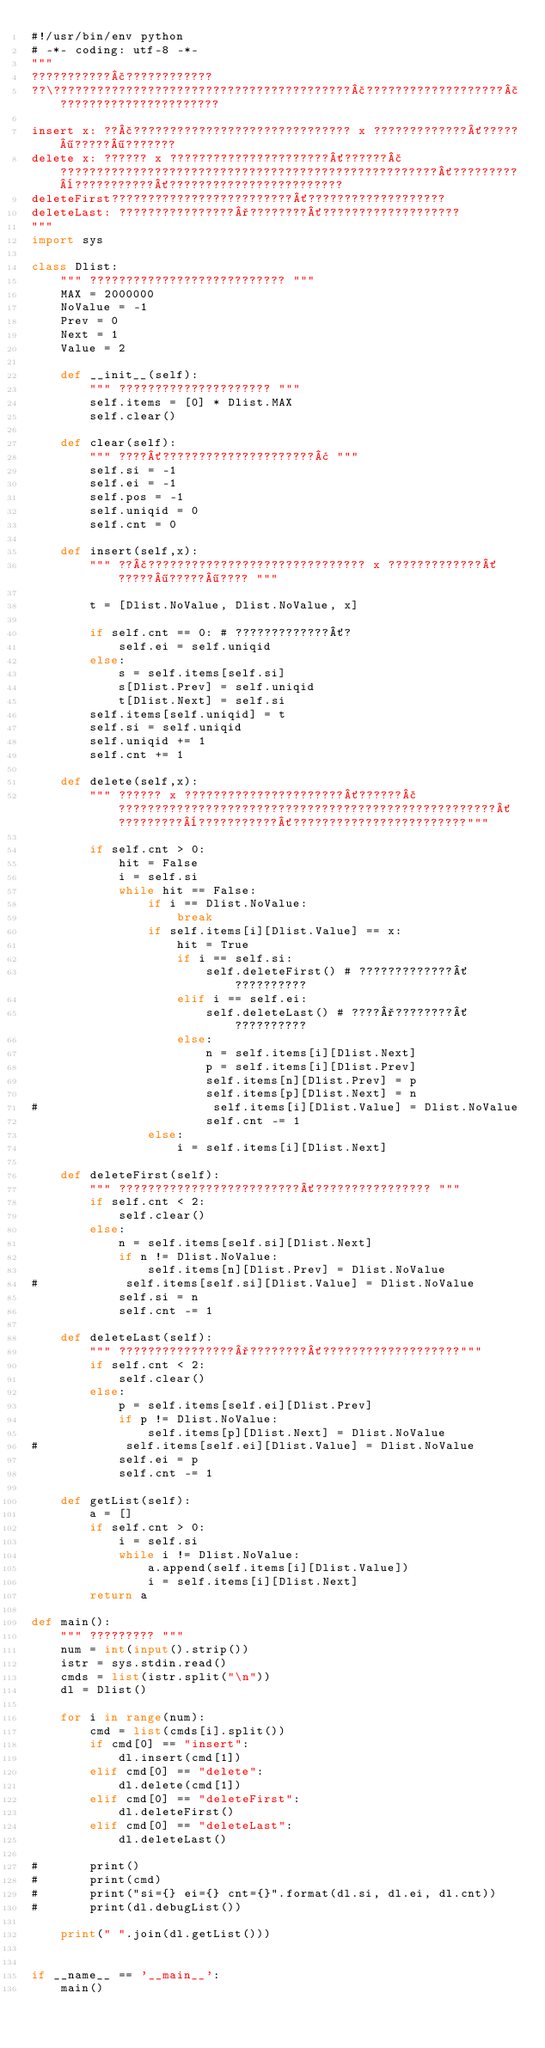<code> <loc_0><loc_0><loc_500><loc_500><_Python_>#!/usr/bin/env python
# -*- coding: utf-8 -*-
"""
???????????£????????????
??\?????????????????????????????????????????£???????????????????£??????????????????????

insert x: ??£?????????????????????????????? x ?????????????´?????¶?????¶???????
delete x: ?????? x ??????????????????????´??????£????????????????????????????????????????????????????´?????????¨???????????´????????????????????????
deleteFirst?????????????????????????´???????????????????
deleteLast: ????????????????°????????´???????????????????
"""
import sys

class Dlist:
    """ ??????????????????????????? """
    MAX = 2000000
    NoValue = -1
    Prev = 0
    Next = 1
    Value = 2

    def __init__(self):
        """ ????????????????????? """
        self.items = [0] * Dlist.MAX
        self.clear()

    def clear(self):
        """ ????´?????????????????????¢ """
        self.si = -1
        self.ei = -1
        self.pos = -1
        self.uniqid = 0
        self.cnt = 0
        
    def insert(self,x):
        """ ??£?????????????????????????????? x ?????????????´?????¶?????¶???? """

        t = [Dlist.NoValue, Dlist.NoValue, x]

        if self.cnt == 0: # ?????????????´?
            self.ei = self.uniqid
        else:
            s = self.items[self.si]
            s[Dlist.Prev] = self.uniqid
            t[Dlist.Next] = self.si
        self.items[self.uniqid] = t
        self.si = self.uniqid
        self.uniqid += 1
        self.cnt += 1
    
    def delete(self,x):
        """ ?????? x ??????????????????????´??????£????????????????????????????????????????????????????´?????????¨???????????´????????????????????????"""

        if self.cnt > 0:
            hit = False
            i = self.si
            while hit == False:
                if i == Dlist.NoValue:
                    break
                if self.items[i][Dlist.Value] == x:
                    hit = True
                    if i == self.si:
                        self.deleteFirst() # ?????????????´??????????
                    elif i == self.ei:
                        self.deleteLast() # ????°????????´??????????
                    else:
                        n = self.items[i][Dlist.Next]
                        p = self.items[i][Dlist.Prev]
                        self.items[n][Dlist.Prev] = p
                        self.items[p][Dlist.Next] = n
#                        self.items[i][Dlist.Value] = Dlist.NoValue
                        self.cnt -= 1
                else:
                    i = self.items[i][Dlist.Next]

    def deleteFirst(self):
        """ ?????????????????????????´???????????????? """
        if self.cnt < 2:
            self.clear()
        else:
            n = self.items[self.si][Dlist.Next]
            if n != Dlist.NoValue:
                self.items[n][Dlist.Prev] = Dlist.NoValue
#            self.items[self.si][Dlist.Value] = Dlist.NoValue
            self.si = n
            self.cnt -= 1

    def deleteLast(self):
        """ ????????????????°????????´???????????????????"""
        if self.cnt < 2:
            self.clear()
        else:
            p = self.items[self.ei][Dlist.Prev]
            if p != Dlist.NoValue:
                self.items[p][Dlist.Next] = Dlist.NoValue
#            self.items[self.ei][Dlist.Value] = Dlist.NoValue
            self.ei = p
            self.cnt -= 1

    def getList(self):
        a = []
        if self.cnt > 0:
            i = self.si
            while i != Dlist.NoValue:
                a.append(self.items[i][Dlist.Value])
                i = self.items[i][Dlist.Next]
        return a

def main():
    """ ????????? """
    num = int(input().strip())
    istr = sys.stdin.read()
    cmds = list(istr.split("\n"))
    dl = Dlist()

    for i in range(num):
        cmd = list(cmds[i].split())
        if cmd[0] == "insert":
            dl.insert(cmd[1])
        elif cmd[0] == "delete":
            dl.delete(cmd[1])
        elif cmd[0] == "deleteFirst":
            dl.deleteFirst()
        elif cmd[0] == "deleteLast":
            dl.deleteLast()

#       print()
#       print(cmd)
#       print("si={} ei={} cnt={}".format(dl.si, dl.ei, dl.cnt))
#       print(dl.debugList())

    print(" ".join(dl.getList()))


if __name__ == '__main__':
    main()</code> 